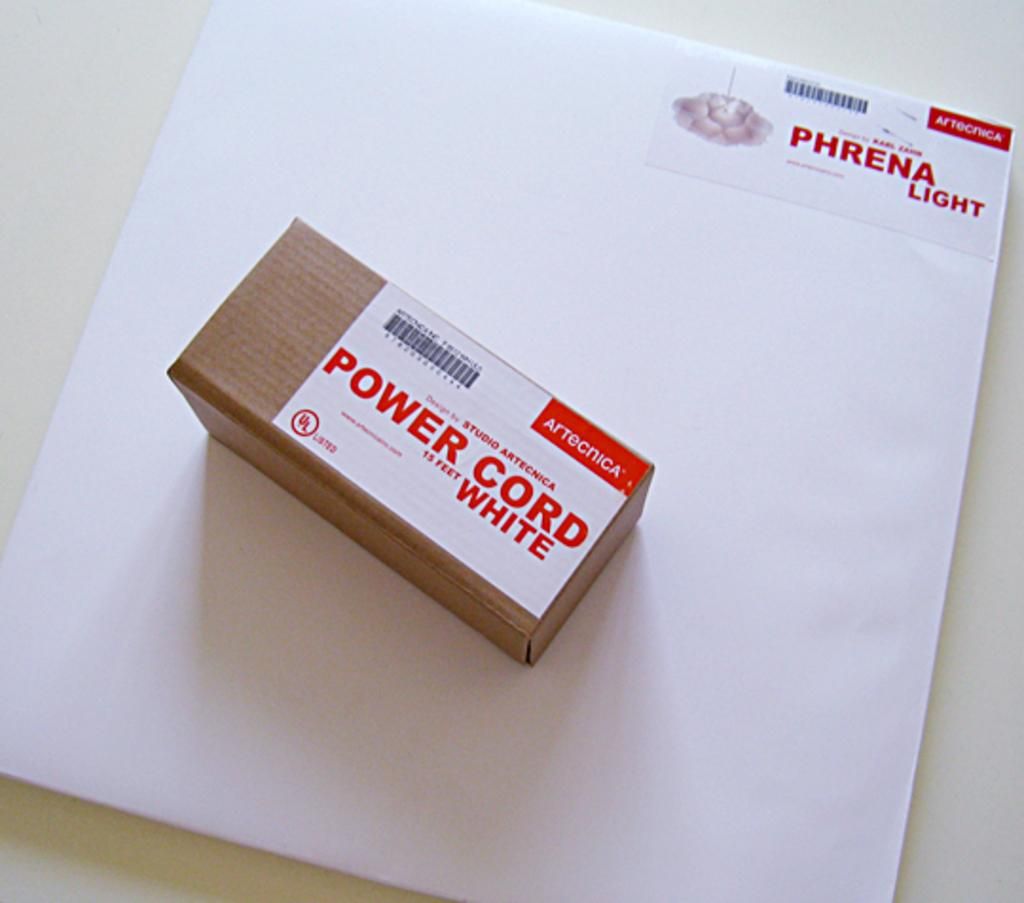<image>
Relay a brief, clear account of the picture shown. a box that says 'power cord 15 feet white' on top of a white envelope 